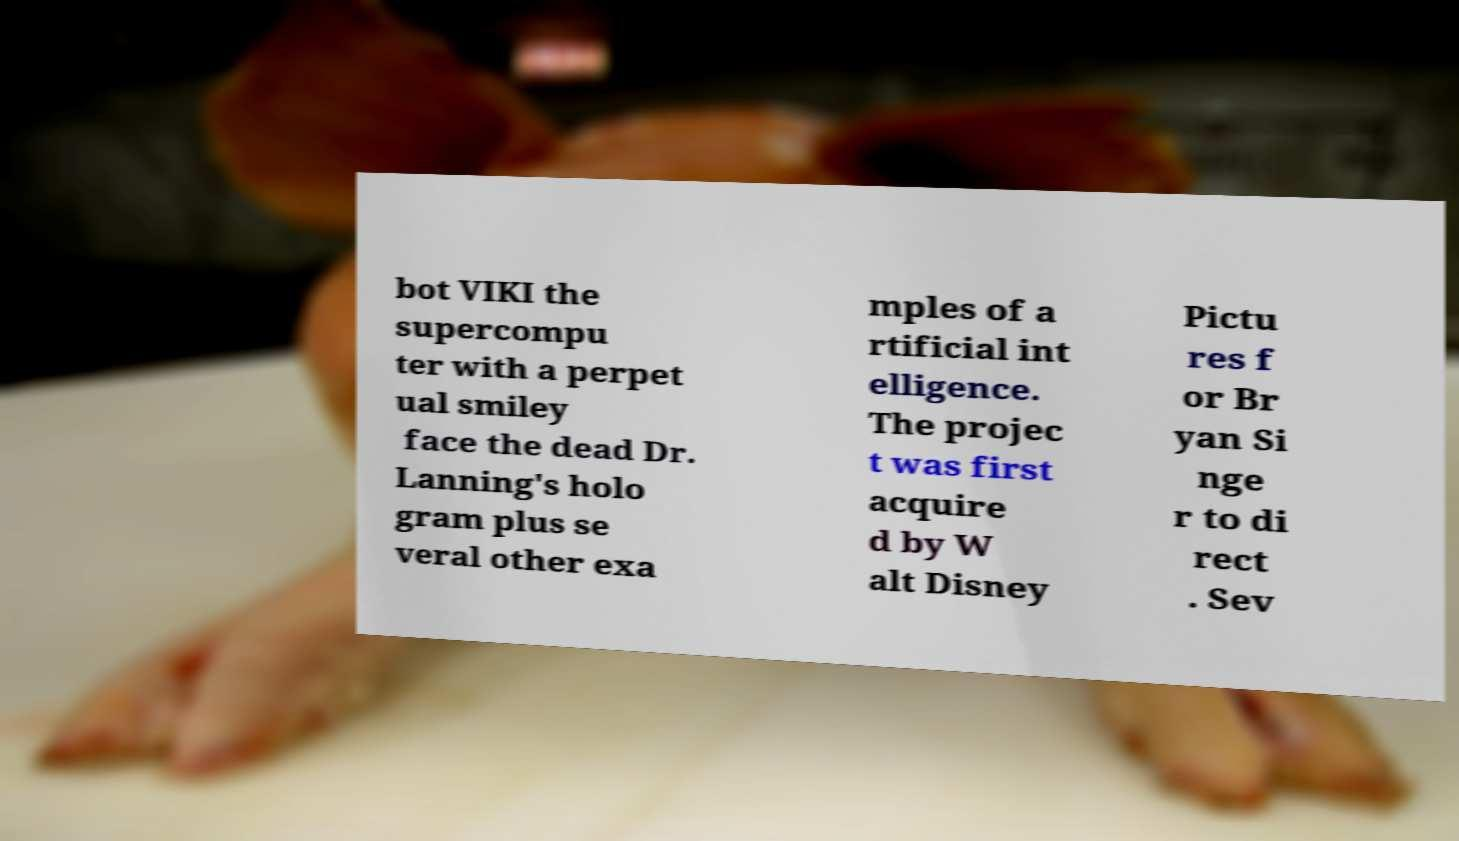Could you extract and type out the text from this image? bot VIKI the supercompu ter with a perpet ual smiley face the dead Dr. Lanning's holo gram plus se veral other exa mples of a rtificial int elligence. The projec t was first acquire d by W alt Disney Pictu res f or Br yan Si nge r to di rect . Sev 